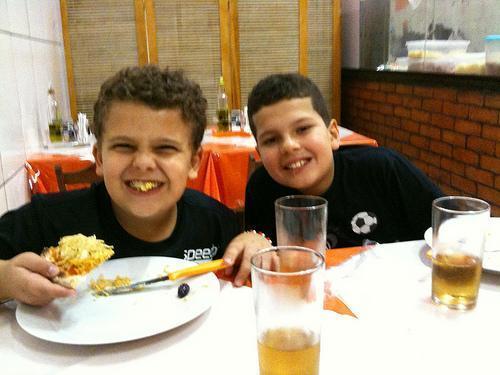How many boys are visible?
Give a very brief answer. 2. 